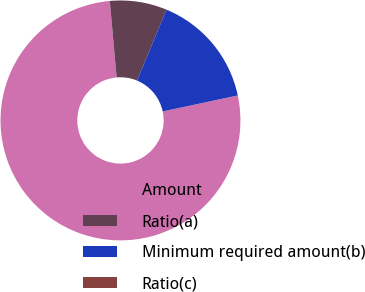Convert chart. <chart><loc_0><loc_0><loc_500><loc_500><pie_chart><fcel>Amount<fcel>Ratio(a)<fcel>Minimum required amount(b)<fcel>Ratio(c)<nl><fcel>76.92%<fcel>7.69%<fcel>15.39%<fcel>0.0%<nl></chart> 